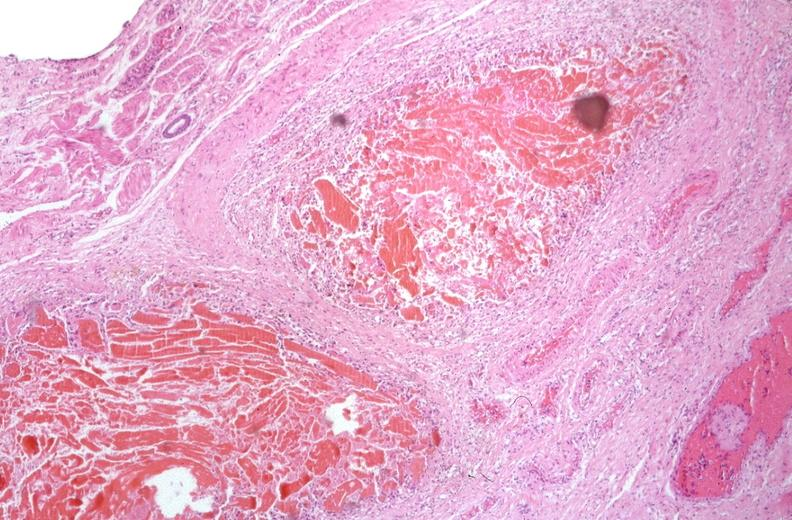does hemochromatosis show esophogus, varices portal hypertension due to cirrhosis, hcv?
Answer the question using a single word or phrase. No 